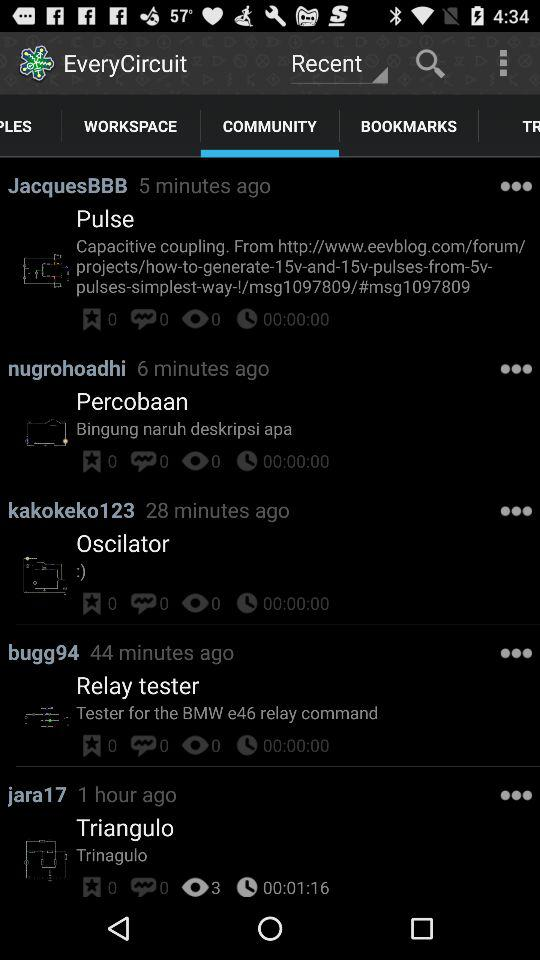How many stars are given to the relay tester? The stars given to the relay tester are 0. 